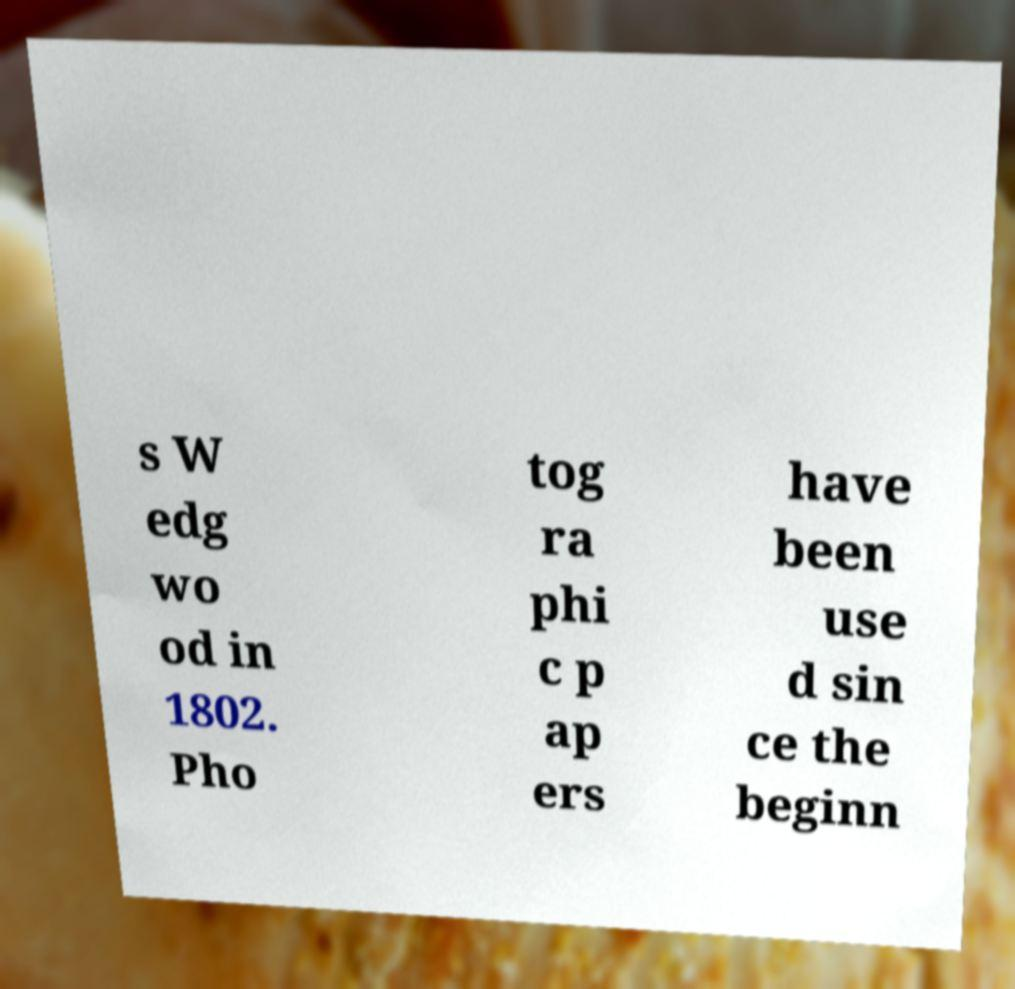For documentation purposes, I need the text within this image transcribed. Could you provide that? s W edg wo od in 1802. Pho tog ra phi c p ap ers have been use d sin ce the beginn 